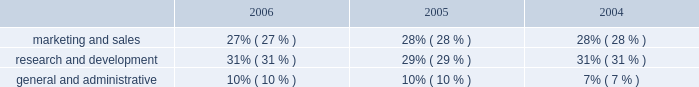Operating expenses as a percentage of total revenue .
Operating expense summary 2006 compared to 2005 overall operating expenses increased $ 122.5 million in 2006 , as compared to 2005 , primarily due to : 2022 an increase of $ 58.4 million in stock-based compensation expense due to our adoption of sfas no .
123r ; and 2022 an increase of $ 49.2 million in salary , benefits and other employee-related costs , primarily due to an increased number of employees and increases in bonus and commission costs , in part due to our acquisition of verisity ltd. , or verisity , in the second quarter of 2005 .
2005 compared to 2004 operating expenses increased $ 97.4 million in 2005 , as compared to 2004 , primarily due to : 2022 an increase of $ 63.3 million in employee salary and benefit costs , primarily due to our acquisition of verisity and increased bonus and commission costs ; 2022 an increase of $ 9.9 million in stock-based compensation expense due to grants of restricted stock and the assumption of options in our acquisitions ; 2022 an increase of $ 8.6 million in losses associated with the sale of installment contract receivables ; and 2022 an increase of $ 7.1 million in costs related to the retirement of our executive chairman and former president and chief executive officer in 2005 ; partially offset by 2022 our restructuring activities , as discussed below .
Marketing and sales 2006 compared to 2005 marketing and sales expenses increased $ 39.4 million in 2006 , as compared to 2005 , primarily due to : 2022 an increase of $ 14.8 million in stock-based compensation expense due to our adoption of sfas no .
123r ; 2022 an increase of $ 18.2 million in employee salary , commissions , benefits and other employee-related costs due to increased hiring of sales and technical personnel , and higher commissions earned resulting from an increase in 2006 sales performance ; and 2022 an increase of $ 7.8 million in marketing programs and customer-focused conferences due to our new marketing initiatives and increased travel to visit our customers .
2005 compared to 2004 marketing and sales expenses increased $ 33.1 million in 2005 , as compared to 2004 , primarily due to : 2022 an increase of $ 29.4 million in employee salary , commission and benefit costs due to increased hiring of sales and technical personnel and higher employee bonuses and commissions ; and 2022 an increase of $ 1.6 million in stock-based compensation expense due to grants of restricted stock and the assumption of options in our acquisitions ; partially offset by 2022 a decrease of $ 1.9 million in marketing program costs. .
What portion of the increase of operating expense in 2006 is incurred by the increase in stock-based compensation expense due to our adoption of sfas no? 
Computations: (58.4 / 122.5)
Answer: 0.47673. 